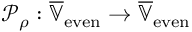Convert formula to latex. <formula><loc_0><loc_0><loc_500><loc_500>\mathcal { P } _ { \rho } \colon \overline { { \mathbb { V } } } _ { e v e n } \rightarrow \overline { { \mathbb { V } } } _ { e v e n }</formula> 